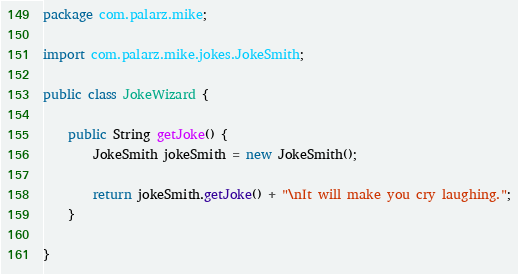<code> <loc_0><loc_0><loc_500><loc_500><_Java_>package com.palarz.mike;

import com.palarz.mike.jokes.JokeSmith;

public class JokeWizard {

    public String getJoke() {
        JokeSmith jokeSmith = new JokeSmith();

        return jokeSmith.getJoke() + "\nIt will make you cry laughing.";
    }

}
</code> 